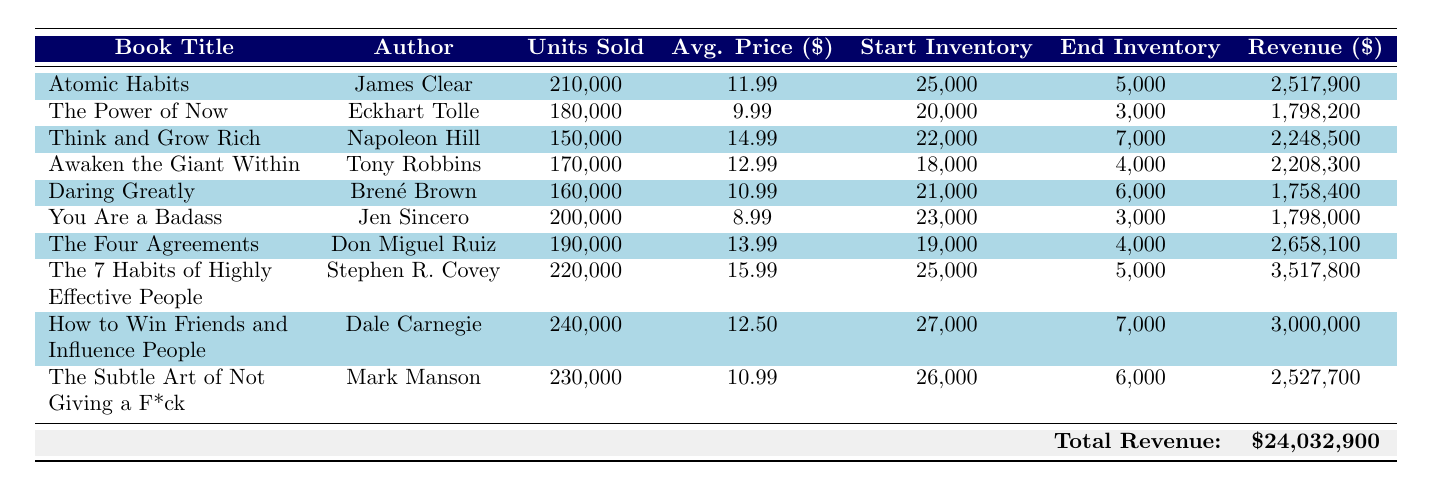What is the total revenue generated by "How to Win Friends and Influence People"? The revenue for "How to Win Friends and Influence People" is directly listed in the table as $3,000,000.
Answer: 3,000,000 Which book had the highest units sold? "How to Win Friends and Influence People" sold 240,000 units, which is the highest in the table compared to the other books.
Answer: How to Win Friends and Influence People What is the average price of "The Four Agreements"? The average price for "The Four Agreements" is listed as $13.99 in the table.
Answer: 13.99 What is the difference in units sold between "Atomic Habits" and "Think and Grow Rich"? "Atomic Habits" sold 210,000 units and "Think and Grow Rich" sold 150,000 units. The difference is calculated by subtracting the units sold for "Think and Grow Rich" from those sold for "Atomic Habits": 210,000 - 150,000 = 60,000.
Answer: 60,000 Did "Daring Greatly" sell more units than "Awaken the Giant Within"? "Daring Greatly" sold 160,000 units while "Awaken the Giant Within" sold 170,000 units. Since 160,000 is less than 170,000, the answer is no.
Answer: No What is the average number of units sold across all books? First, sum the total units sold: 210,000 + 180,000 + 150,000 + 170,000 + 160,000 + 200,000 + 190,000 + 220,000 + 240,000 + 230,000 = 2,080,000. Then, there are 10 books, so the average is 2,080,000 / 10 = 208,000.
Answer: 208,000 How much inventory did "You Are a Badass" have at the start of the year? The starting inventory for "You Are a Badass" is listed as 23,000 in the table.
Answer: 23,000 Which author's book sold the least number of units? "Think and Grow Rich" by Napoleon Hill sold 150,000 units, which is the lowest compared to the other books listed in the table.
Answer: Think and Grow Rich 